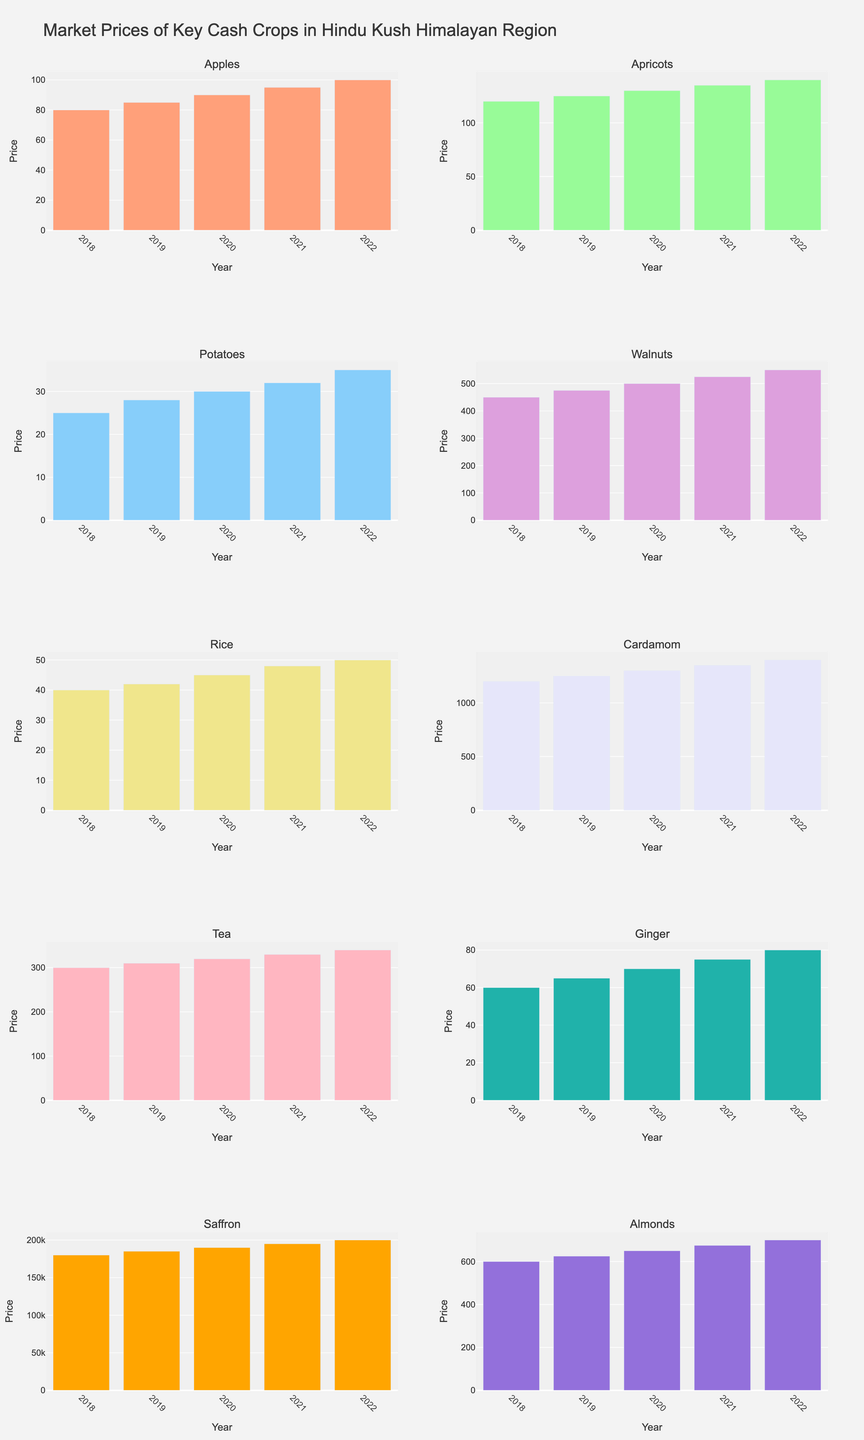Which crop had the highest market price in 2022? Look at the bars for the year 2022 across all subplots and identify the tallest one, which represents the highest market price.
Answer: Saffron What is the difference in the price of Walnuts in 2022 and 2018? Find the height of the bars for Walnuts in both 2018 and 2022, then subtract the 2018 value from the 2022 value: 550 - 450 = 100.
Answer: 100 Which trading center saw the smallest increase in the price of its crop from 2018 to 2022? Calculate the increase in prices from 2018 to 2022 for each trading center, and identify the smallest increase. For example, for Potatoes in Shimla: 35 - 25 = 10.
Answer: Shimla (Potatoes) Compare the price trends of Apples and Apricots over the years. Do they show a similar trend? Look at the pattern of the bars for Apples and Apricots from 2018 to 2022. Both show a consistent year-on-year increase.
Answer: Yes What is the average market price of Cardamom from 2018 to 2022? Calculate the average of the values from 2018 to 2022: (1200 + 1250 + 1300 + 1350 + 1400) / 5 = 1300.
Answer: 1300 In which year did Ginger have the lowest market price, and what was it? Identify the shortest bar representing Ginger across the years. The shortest bar is in 2018, with a value of 60.
Answer: 2018, 60 Which crop had a more significant price increase from 2018 to 2022, Almonds or Ginger? Calculate the price increase for each crop: Almonds: 700 - 600 = 100, Ginger: 80 - 60 = 20.
Answer: Almonds By how much did the price of Tea in Darjeeling increase from 2019 to 2021? Find the height of the bars for Tea in 2019 and 2021, then subtract the 2019 value from the 2021 value: 330 - 310 = 20.
Answer: 20 What is the combined market price of Rice and Walnuts in 2020? Sum the market prices of Rice (45) and Walnuts (500) in 2020: 45 + 500 = 545.
Answer: 545 